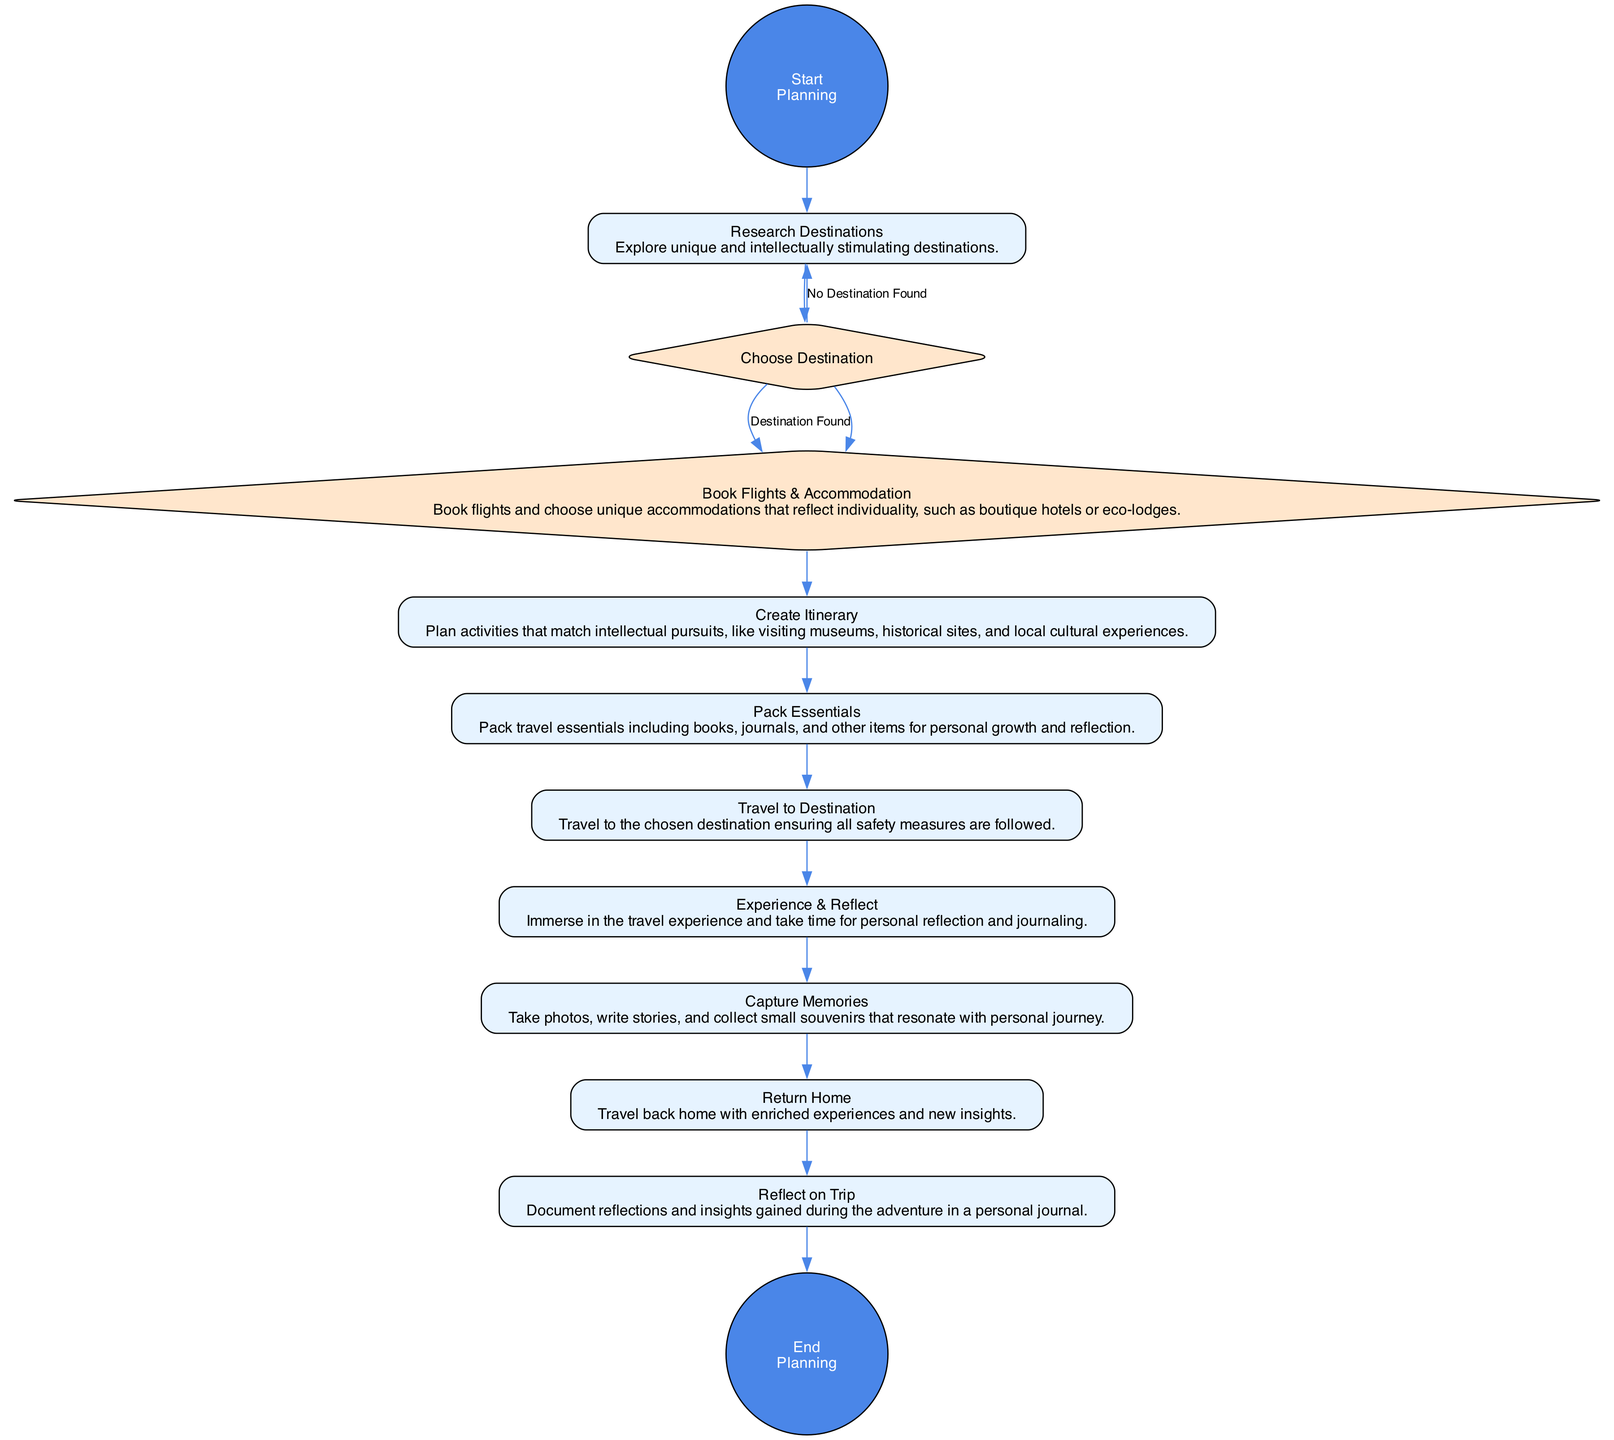What is the first action in the diagram? The diagram begins with the "Start Planning" node, then proceeds directly to the first action node, which is "Research Destinations."
Answer: Research Destinations How many decision nodes are present in the diagram? There are two decision nodes: "Choose Destination" and one return decision back to "Research Destinations" if no destination is found.
Answer: 1 What is the final action before reaching the end of the planning process? The last action that occurs before reaching the "End Planning" node is "Reflect on Trip." This follows the completion of the whole trip experience.
Answer: Reflect on Trip Which action follows "Book Flights & Accommodation"? After completing the action of "Book Flights & Accommodation," the next action that follows is "Create Itinerary." This occurs sequentially in the planning process.
Answer: Create Itinerary What happens if a destination is not found in the decision about choosing a destination? If no destination is found, the flow returns to the "Research Destinations" action, allowing for additional exploration of options.
Answer: Research Destinations What is one essential item to pack according to the diagram? The diagram specifies that one essential item to pack is "books," which underscores the focus on personal growth and interests during travel.
Answer: books 